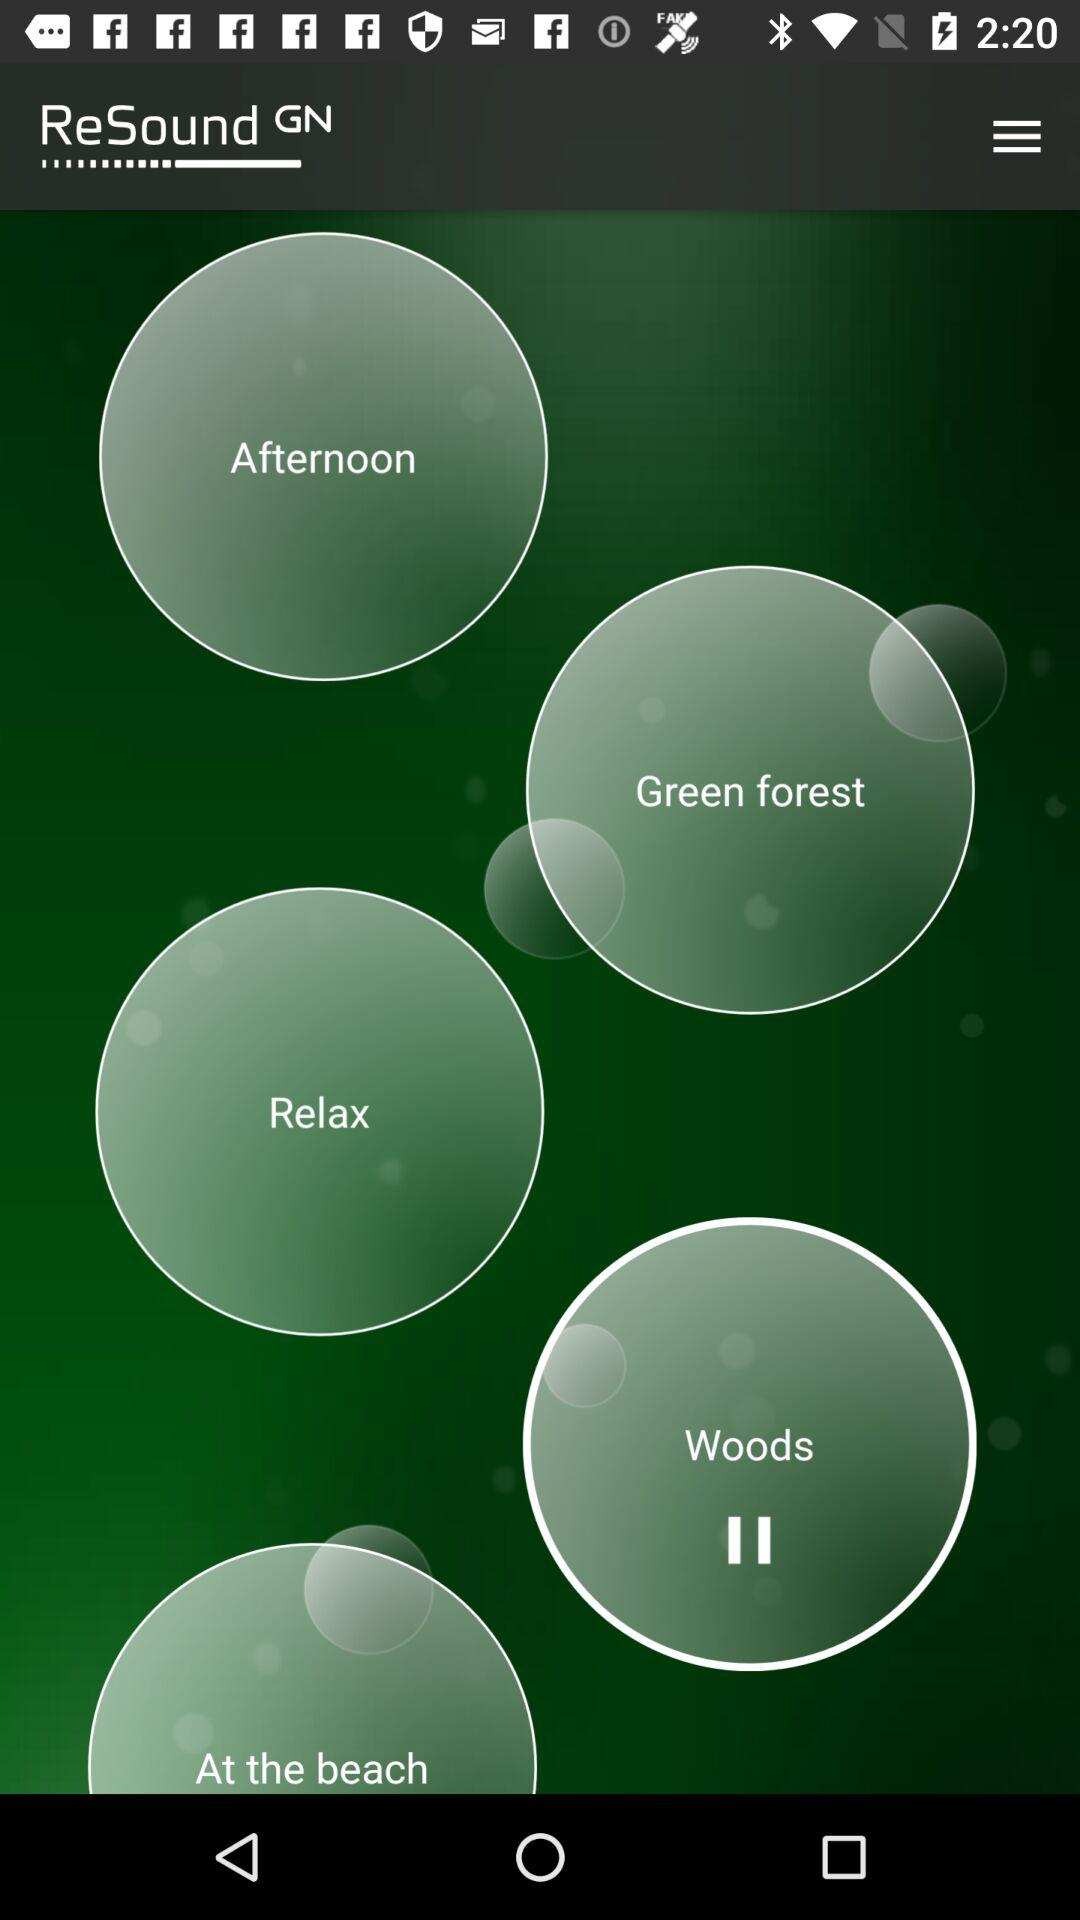How long is the "Woods" sound?
When the provided information is insufficient, respond with <no answer>. <no answer> 